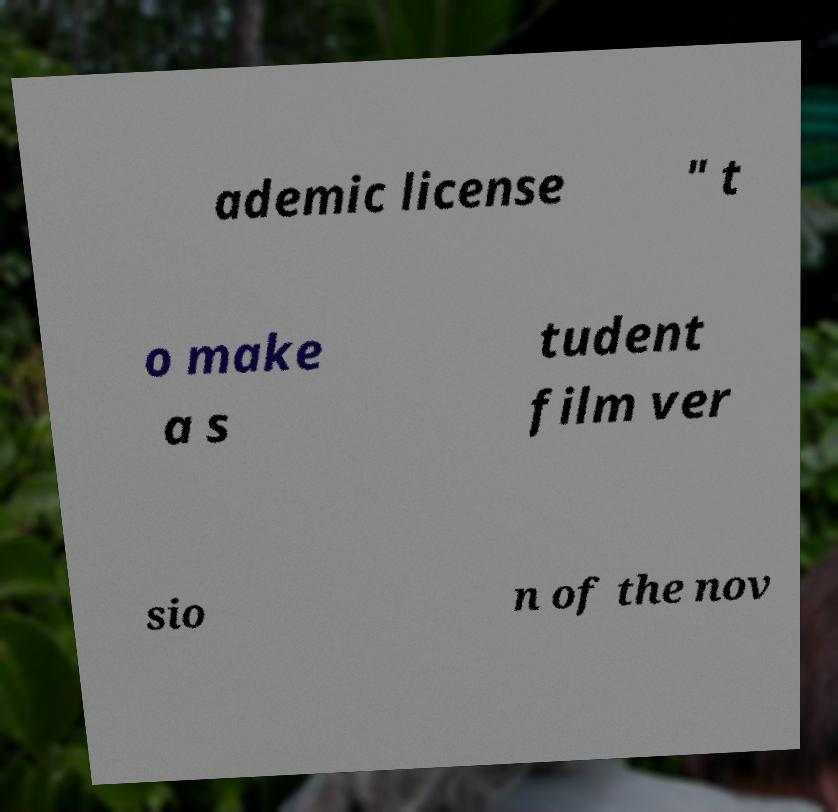Could you extract and type out the text from this image? ademic license " t o make a s tudent film ver sio n of the nov 